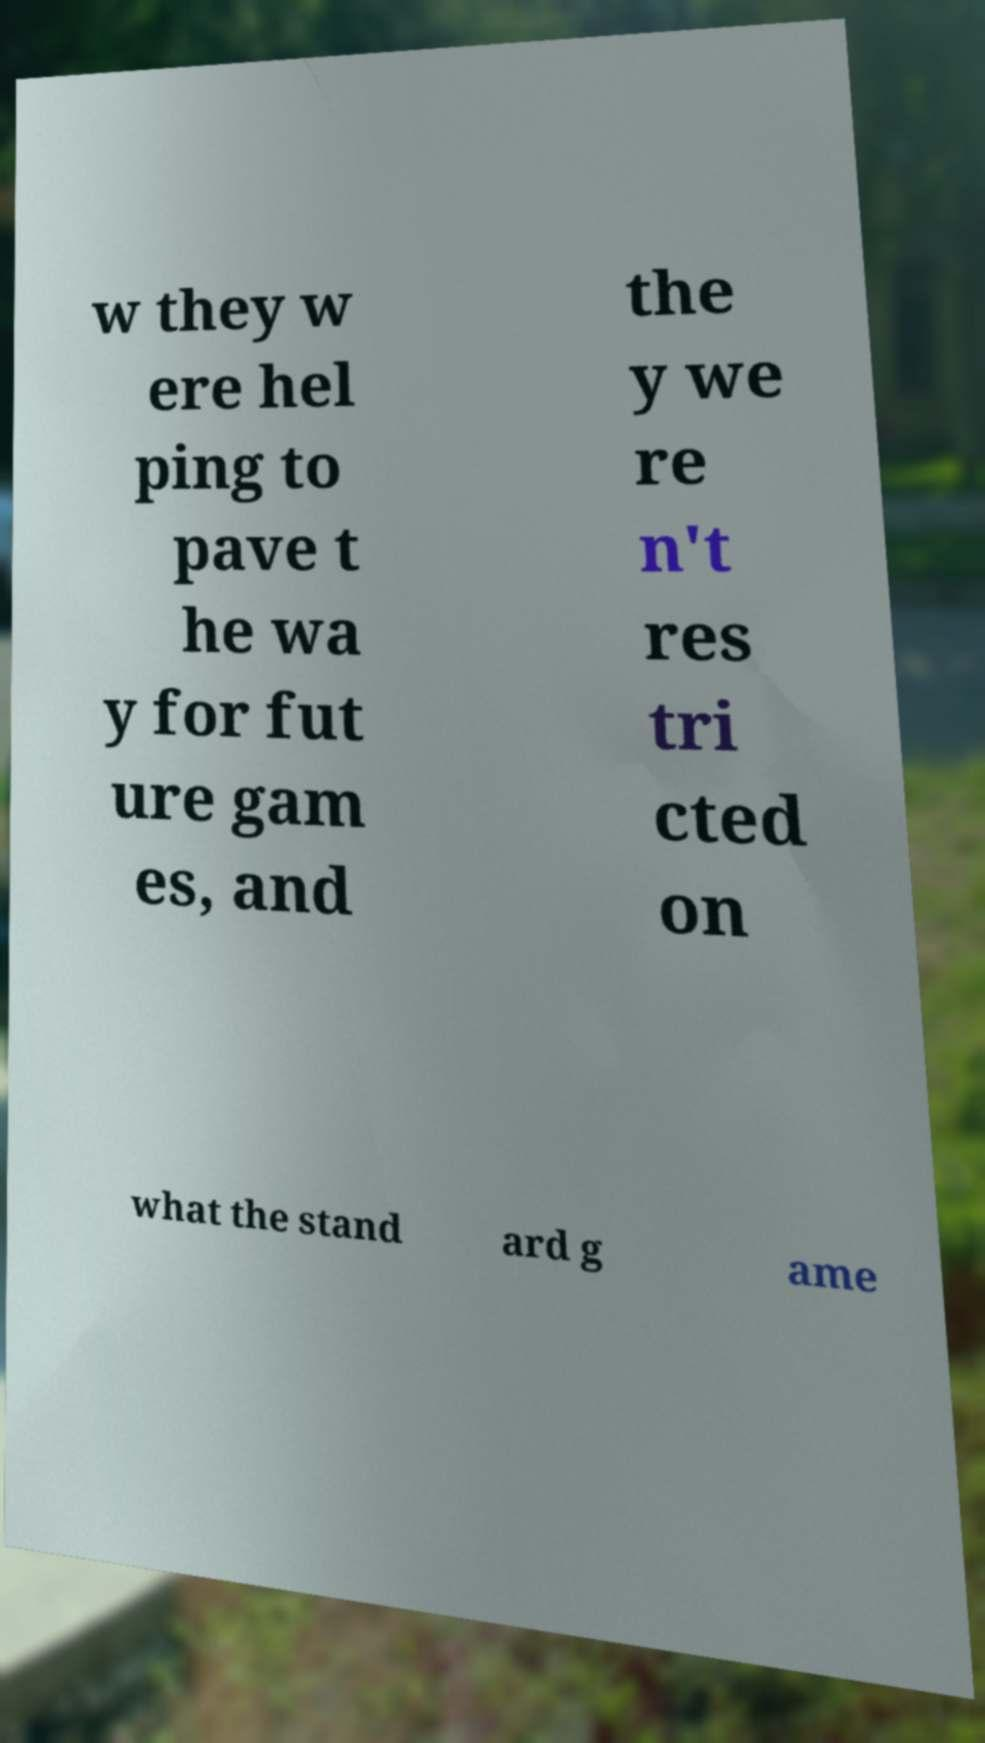For documentation purposes, I need the text within this image transcribed. Could you provide that? w they w ere hel ping to pave t he wa y for fut ure gam es, and the y we re n't res tri cted on what the stand ard g ame 